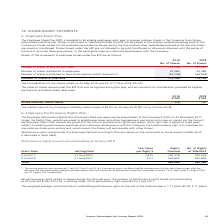According to Hansen Technologies's financial document, How much was the consideration for the shares issued on 22 May 2019? According to the financial document, $3.72. The relevant text states: "ideration for the shares issued on 22 May 2019 was $3.72 (7 May 2018: $4.24)...." Also, How much was the consideration for the shares issued on 7 May 2018? According to the financial document, $4.24. The relevant text states: "hares issued on 22 May 2019 was $3.72 (7 May 2018: $4.24)...." Also, How many shares were distributed to employees in 2018? According to the financial document, 42,480. The relevant text states: "Number of shares distributed to employees 45,560 42,480..." Also, can you calculate: What was the 2019 percentage change in number of shares distributed to employees? To answer this question, I need to perform calculations using the financial data. The calculation is: (45,560 - 42,480) / 42,480 , which equals 7.25 (percentage). This is based on the information: "Number of shares distributed to employees 45,560 42,480 Number of shares distributed to employees 45,560 42,480..." The key data points involved are: 42,480, 45,560. Also, can you calculate: What was the difference between the number of shares at the beginning and end of year 2019? Based on the calculation: 115,792 - 114,758 , the result is 1034. This is based on the information: "Number of shares at year end 115,792 114,758 Number of shares at year end 115,792 114,758..." The key data points involved are: 114,758, 115,792. Also, can you calculate: What was the average number of shares at year end for both years? To answer this question, I need to perform calculations using the financial data. The calculation is: (115,792 + 114,758) / 2 , which equals 115275. This is based on the information: "Number of shares at year end 115,792 114,758 Number of shares at year end 115,792 114,758..." The key data points involved are: 114,758, 115,792. 